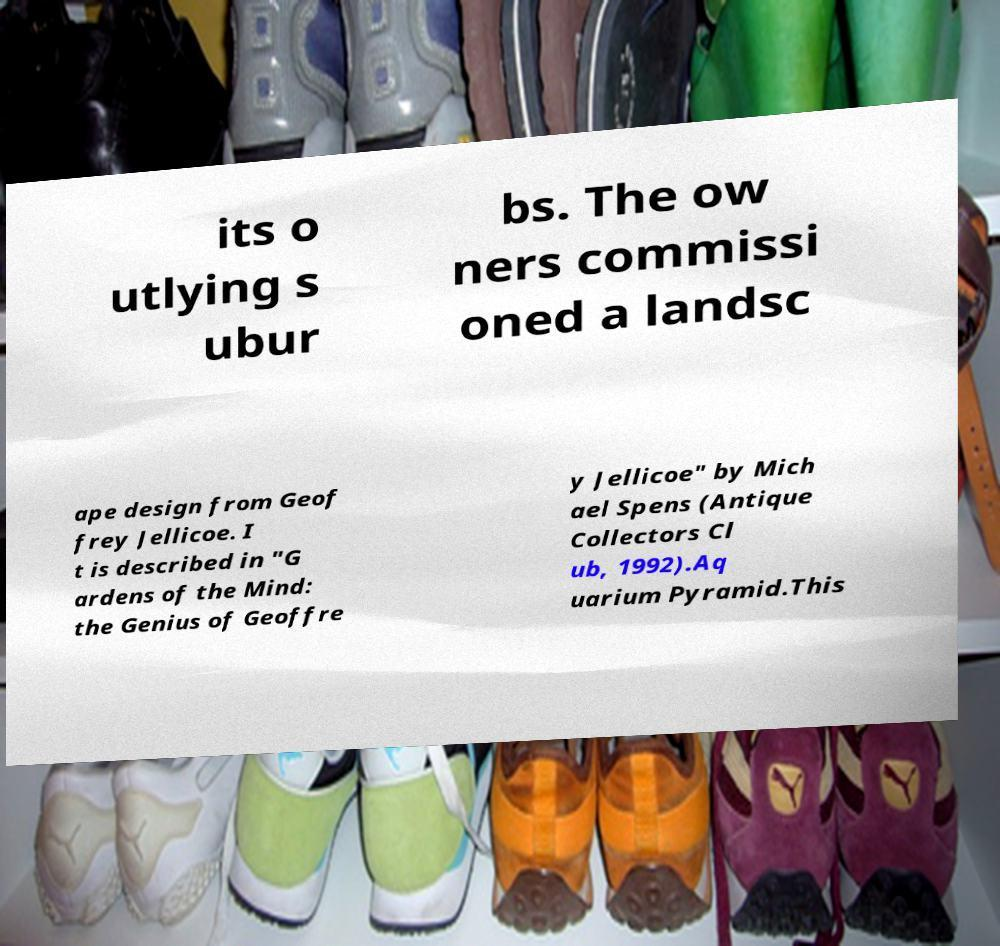Could you assist in decoding the text presented in this image and type it out clearly? its o utlying s ubur bs. The ow ners commissi oned a landsc ape design from Geof frey Jellicoe. I t is described in "G ardens of the Mind: the Genius of Geoffre y Jellicoe" by Mich ael Spens (Antique Collectors Cl ub, 1992).Aq uarium Pyramid.This 